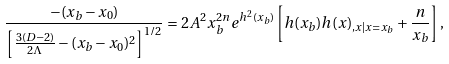Convert formula to latex. <formula><loc_0><loc_0><loc_500><loc_500>\frac { - ( x _ { b } - x _ { 0 } ) } { \left [ \frac { 3 ( D - 2 ) } { 2 \Lambda } - ( x _ { b } - x _ { 0 } ) ^ { 2 } \right ] ^ { 1 / 2 } } = 2 A ^ { 2 } x _ { b } ^ { 2 n } e ^ { h ^ { 2 } ( x _ { b } ) } \left [ h ( x _ { b } ) h ( x ) _ { , x | x = x _ { b } } + \frac { n } { x _ { b } } \right ] ,</formula> 